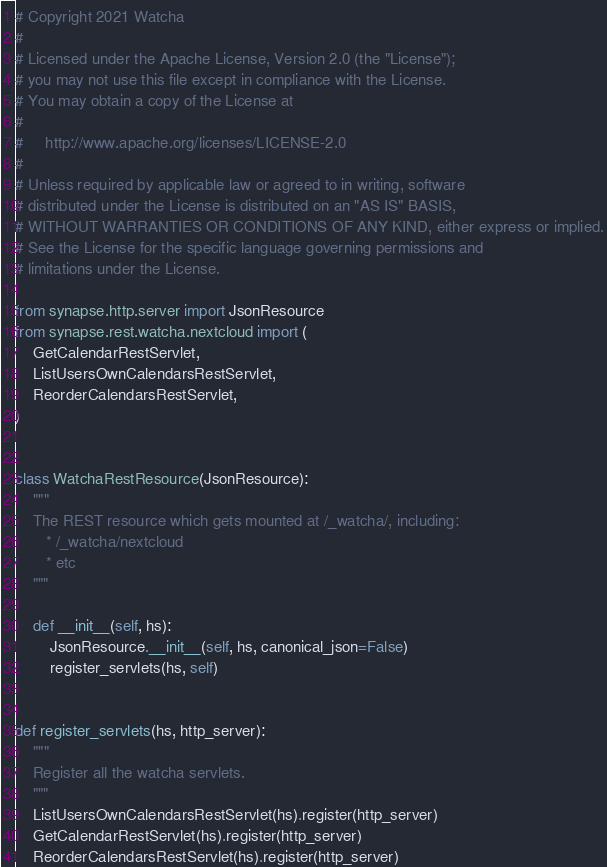Convert code to text. <code><loc_0><loc_0><loc_500><loc_500><_Python_># Copyright 2021 Watcha
#
# Licensed under the Apache License, Version 2.0 (the "License");
# you may not use this file except in compliance with the License.
# You may obtain a copy of the License at
#
#     http://www.apache.org/licenses/LICENSE-2.0
#
# Unless required by applicable law or agreed to in writing, software
# distributed under the License is distributed on an "AS IS" BASIS,
# WITHOUT WARRANTIES OR CONDITIONS OF ANY KIND, either express or implied.
# See the License for the specific language governing permissions and
# limitations under the License.

from synapse.http.server import JsonResource
from synapse.rest.watcha.nextcloud import (
    GetCalendarRestServlet,
    ListUsersOwnCalendarsRestServlet,
    ReorderCalendarsRestServlet,
)


class WatchaRestResource(JsonResource):
    """
    The REST resource which gets mounted at /_watcha/, including:
       * /_watcha/nextcloud
       * etc
    """

    def __init__(self, hs):
        JsonResource.__init__(self, hs, canonical_json=False)
        register_servlets(hs, self)


def register_servlets(hs, http_server):
    """
    Register all the watcha servlets.
    """
    ListUsersOwnCalendarsRestServlet(hs).register(http_server)
    GetCalendarRestServlet(hs).register(http_server)
    ReorderCalendarsRestServlet(hs).register(http_server)
</code> 